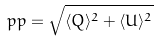<formula> <loc_0><loc_0><loc_500><loc_500>p p = \sqrt { \langle Q \rangle ^ { 2 } + \langle U \rangle ^ { 2 } }</formula> 